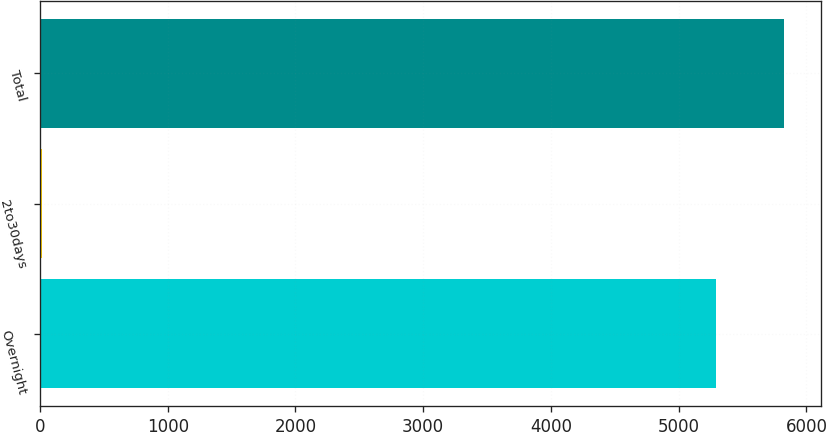Convert chart to OTSL. <chart><loc_0><loc_0><loc_500><loc_500><bar_chart><fcel>Overnight<fcel>2to30days<fcel>Total<nl><fcel>5295<fcel>15<fcel>5824.5<nl></chart> 